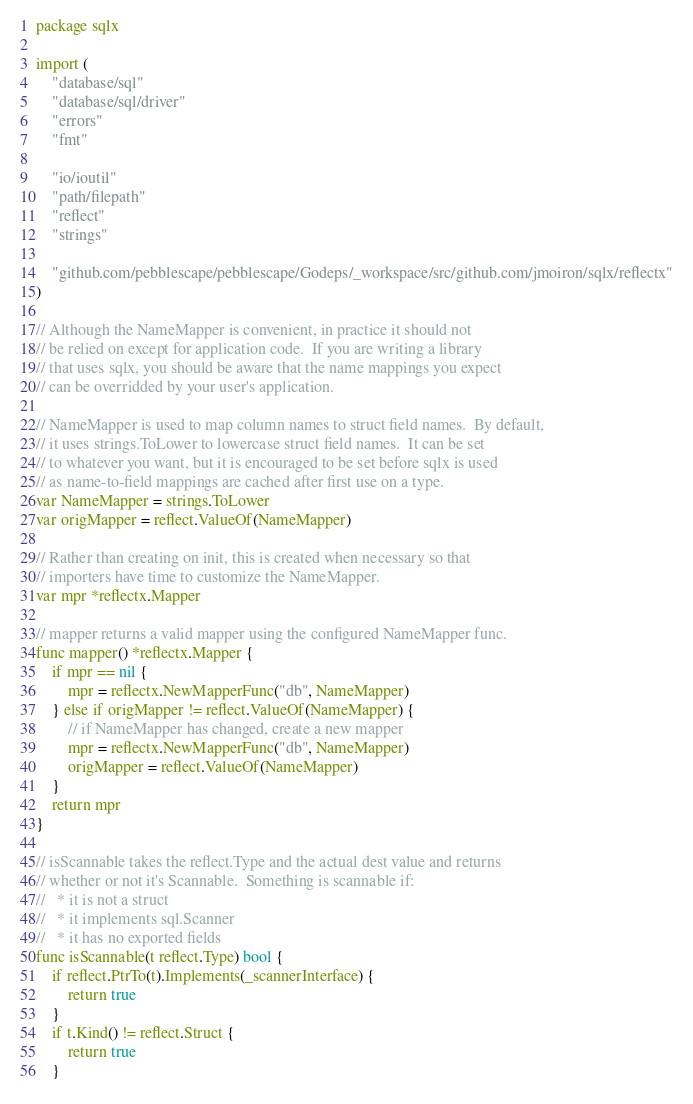Convert code to text. <code><loc_0><loc_0><loc_500><loc_500><_Go_>package sqlx

import (
	"database/sql"
	"database/sql/driver"
	"errors"
	"fmt"

	"io/ioutil"
	"path/filepath"
	"reflect"
	"strings"

	"github.com/pebblescape/pebblescape/Godeps/_workspace/src/github.com/jmoiron/sqlx/reflectx"
)

// Although the NameMapper is convenient, in practice it should not
// be relied on except for application code.  If you are writing a library
// that uses sqlx, you should be aware that the name mappings you expect
// can be overridded by your user's application.

// NameMapper is used to map column names to struct field names.  By default,
// it uses strings.ToLower to lowercase struct field names.  It can be set
// to whatever you want, but it is encouraged to be set before sqlx is used
// as name-to-field mappings are cached after first use on a type.
var NameMapper = strings.ToLower
var origMapper = reflect.ValueOf(NameMapper)

// Rather than creating on init, this is created when necessary so that
// importers have time to customize the NameMapper.
var mpr *reflectx.Mapper

// mapper returns a valid mapper using the configured NameMapper func.
func mapper() *reflectx.Mapper {
	if mpr == nil {
		mpr = reflectx.NewMapperFunc("db", NameMapper)
	} else if origMapper != reflect.ValueOf(NameMapper) {
		// if NameMapper has changed, create a new mapper
		mpr = reflectx.NewMapperFunc("db", NameMapper)
		origMapper = reflect.ValueOf(NameMapper)
	}
	return mpr
}

// isScannable takes the reflect.Type and the actual dest value and returns
// whether or not it's Scannable.  Something is scannable if:
//   * it is not a struct
//   * it implements sql.Scanner
//   * it has no exported fields
func isScannable(t reflect.Type) bool {
	if reflect.PtrTo(t).Implements(_scannerInterface) {
		return true
	}
	if t.Kind() != reflect.Struct {
		return true
	}
</code> 